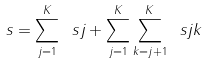<formula> <loc_0><loc_0><loc_500><loc_500>\ s = \sum _ { j = 1 } ^ { K } \ s j + \sum _ { j = 1 } ^ { K } \sum _ { k = j + 1 } ^ { K } \ s j k</formula> 